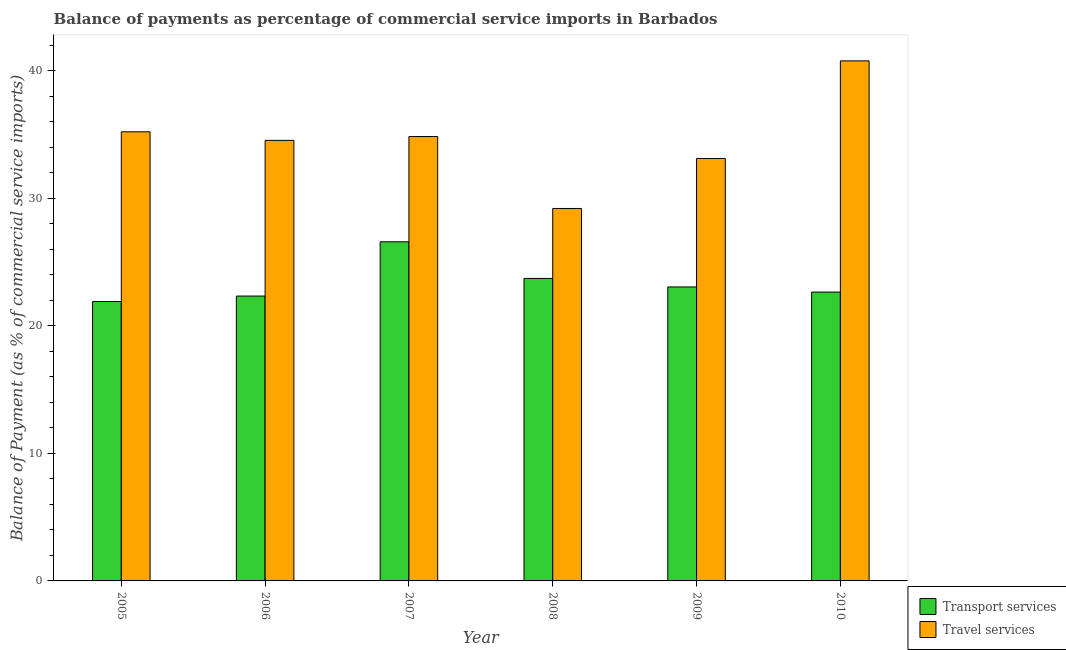How many different coloured bars are there?
Your response must be concise. 2. How many groups of bars are there?
Your response must be concise. 6. How many bars are there on the 1st tick from the right?
Offer a very short reply. 2. What is the label of the 2nd group of bars from the left?
Make the answer very short. 2006. What is the balance of payments of transport services in 2009?
Make the answer very short. 23.05. Across all years, what is the maximum balance of payments of transport services?
Offer a very short reply. 26.58. Across all years, what is the minimum balance of payments of travel services?
Offer a very short reply. 29.2. What is the total balance of payments of transport services in the graph?
Offer a very short reply. 140.22. What is the difference between the balance of payments of transport services in 2007 and that in 2008?
Keep it short and to the point. 2.87. What is the difference between the balance of payments of transport services in 2010 and the balance of payments of travel services in 2007?
Your response must be concise. -3.94. What is the average balance of payments of travel services per year?
Your answer should be compact. 34.61. What is the ratio of the balance of payments of transport services in 2007 to that in 2009?
Offer a very short reply. 1.15. Is the balance of payments of travel services in 2006 less than that in 2007?
Your answer should be very brief. Yes. What is the difference between the highest and the second highest balance of payments of travel services?
Offer a terse response. 5.56. What is the difference between the highest and the lowest balance of payments of transport services?
Provide a succinct answer. 4.68. What does the 1st bar from the left in 2008 represents?
Your response must be concise. Transport services. What does the 2nd bar from the right in 2006 represents?
Your answer should be very brief. Transport services. Are all the bars in the graph horizontal?
Give a very brief answer. No. What is the difference between two consecutive major ticks on the Y-axis?
Provide a succinct answer. 10. Does the graph contain any zero values?
Offer a terse response. No. Does the graph contain grids?
Offer a very short reply. No. What is the title of the graph?
Give a very brief answer. Balance of payments as percentage of commercial service imports in Barbados. What is the label or title of the X-axis?
Provide a succinct answer. Year. What is the label or title of the Y-axis?
Provide a succinct answer. Balance of Payment (as % of commercial service imports). What is the Balance of Payment (as % of commercial service imports) of Transport services in 2005?
Give a very brief answer. 21.91. What is the Balance of Payment (as % of commercial service imports) of Travel services in 2005?
Provide a succinct answer. 35.21. What is the Balance of Payment (as % of commercial service imports) in Transport services in 2006?
Provide a succinct answer. 22.33. What is the Balance of Payment (as % of commercial service imports) in Travel services in 2006?
Keep it short and to the point. 34.54. What is the Balance of Payment (as % of commercial service imports) of Transport services in 2007?
Give a very brief answer. 26.58. What is the Balance of Payment (as % of commercial service imports) of Travel services in 2007?
Provide a succinct answer. 34.84. What is the Balance of Payment (as % of commercial service imports) of Transport services in 2008?
Provide a succinct answer. 23.71. What is the Balance of Payment (as % of commercial service imports) in Travel services in 2008?
Offer a terse response. 29.2. What is the Balance of Payment (as % of commercial service imports) in Transport services in 2009?
Ensure brevity in your answer.  23.05. What is the Balance of Payment (as % of commercial service imports) in Travel services in 2009?
Keep it short and to the point. 33.12. What is the Balance of Payment (as % of commercial service imports) of Transport services in 2010?
Your answer should be very brief. 22.64. What is the Balance of Payment (as % of commercial service imports) in Travel services in 2010?
Offer a terse response. 40.77. Across all years, what is the maximum Balance of Payment (as % of commercial service imports) in Transport services?
Your answer should be compact. 26.58. Across all years, what is the maximum Balance of Payment (as % of commercial service imports) in Travel services?
Give a very brief answer. 40.77. Across all years, what is the minimum Balance of Payment (as % of commercial service imports) in Transport services?
Your answer should be very brief. 21.91. Across all years, what is the minimum Balance of Payment (as % of commercial service imports) in Travel services?
Give a very brief answer. 29.2. What is the total Balance of Payment (as % of commercial service imports) of Transport services in the graph?
Provide a succinct answer. 140.22. What is the total Balance of Payment (as % of commercial service imports) in Travel services in the graph?
Offer a terse response. 207.66. What is the difference between the Balance of Payment (as % of commercial service imports) of Transport services in 2005 and that in 2006?
Make the answer very short. -0.43. What is the difference between the Balance of Payment (as % of commercial service imports) of Travel services in 2005 and that in 2006?
Provide a succinct answer. 0.67. What is the difference between the Balance of Payment (as % of commercial service imports) in Transport services in 2005 and that in 2007?
Keep it short and to the point. -4.68. What is the difference between the Balance of Payment (as % of commercial service imports) of Travel services in 2005 and that in 2007?
Offer a very short reply. 0.37. What is the difference between the Balance of Payment (as % of commercial service imports) in Transport services in 2005 and that in 2008?
Offer a terse response. -1.81. What is the difference between the Balance of Payment (as % of commercial service imports) of Travel services in 2005 and that in 2008?
Provide a succinct answer. 6.01. What is the difference between the Balance of Payment (as % of commercial service imports) of Transport services in 2005 and that in 2009?
Provide a short and direct response. -1.14. What is the difference between the Balance of Payment (as % of commercial service imports) in Travel services in 2005 and that in 2009?
Make the answer very short. 2.09. What is the difference between the Balance of Payment (as % of commercial service imports) in Transport services in 2005 and that in 2010?
Make the answer very short. -0.74. What is the difference between the Balance of Payment (as % of commercial service imports) of Travel services in 2005 and that in 2010?
Offer a terse response. -5.56. What is the difference between the Balance of Payment (as % of commercial service imports) in Transport services in 2006 and that in 2007?
Offer a very short reply. -4.25. What is the difference between the Balance of Payment (as % of commercial service imports) in Travel services in 2006 and that in 2007?
Provide a short and direct response. -0.3. What is the difference between the Balance of Payment (as % of commercial service imports) in Transport services in 2006 and that in 2008?
Make the answer very short. -1.38. What is the difference between the Balance of Payment (as % of commercial service imports) of Travel services in 2006 and that in 2008?
Your answer should be compact. 5.34. What is the difference between the Balance of Payment (as % of commercial service imports) in Transport services in 2006 and that in 2009?
Provide a succinct answer. -0.71. What is the difference between the Balance of Payment (as % of commercial service imports) of Travel services in 2006 and that in 2009?
Provide a short and direct response. 1.42. What is the difference between the Balance of Payment (as % of commercial service imports) of Transport services in 2006 and that in 2010?
Make the answer very short. -0.31. What is the difference between the Balance of Payment (as % of commercial service imports) in Travel services in 2006 and that in 2010?
Keep it short and to the point. -6.23. What is the difference between the Balance of Payment (as % of commercial service imports) in Transport services in 2007 and that in 2008?
Your answer should be compact. 2.87. What is the difference between the Balance of Payment (as % of commercial service imports) of Travel services in 2007 and that in 2008?
Provide a succinct answer. 5.64. What is the difference between the Balance of Payment (as % of commercial service imports) of Transport services in 2007 and that in 2009?
Your answer should be compact. 3.54. What is the difference between the Balance of Payment (as % of commercial service imports) in Travel services in 2007 and that in 2009?
Offer a terse response. 1.72. What is the difference between the Balance of Payment (as % of commercial service imports) in Transport services in 2007 and that in 2010?
Make the answer very short. 3.94. What is the difference between the Balance of Payment (as % of commercial service imports) of Travel services in 2007 and that in 2010?
Provide a short and direct response. -5.93. What is the difference between the Balance of Payment (as % of commercial service imports) in Transport services in 2008 and that in 2009?
Make the answer very short. 0.67. What is the difference between the Balance of Payment (as % of commercial service imports) of Travel services in 2008 and that in 2009?
Ensure brevity in your answer.  -3.92. What is the difference between the Balance of Payment (as % of commercial service imports) in Transport services in 2008 and that in 2010?
Your response must be concise. 1.07. What is the difference between the Balance of Payment (as % of commercial service imports) in Travel services in 2008 and that in 2010?
Offer a very short reply. -11.57. What is the difference between the Balance of Payment (as % of commercial service imports) of Transport services in 2009 and that in 2010?
Your answer should be very brief. 0.4. What is the difference between the Balance of Payment (as % of commercial service imports) of Travel services in 2009 and that in 2010?
Ensure brevity in your answer.  -7.65. What is the difference between the Balance of Payment (as % of commercial service imports) of Transport services in 2005 and the Balance of Payment (as % of commercial service imports) of Travel services in 2006?
Provide a succinct answer. -12.63. What is the difference between the Balance of Payment (as % of commercial service imports) of Transport services in 2005 and the Balance of Payment (as % of commercial service imports) of Travel services in 2007?
Give a very brief answer. -12.93. What is the difference between the Balance of Payment (as % of commercial service imports) in Transport services in 2005 and the Balance of Payment (as % of commercial service imports) in Travel services in 2008?
Offer a very short reply. -7.29. What is the difference between the Balance of Payment (as % of commercial service imports) in Transport services in 2005 and the Balance of Payment (as % of commercial service imports) in Travel services in 2009?
Give a very brief answer. -11.21. What is the difference between the Balance of Payment (as % of commercial service imports) in Transport services in 2005 and the Balance of Payment (as % of commercial service imports) in Travel services in 2010?
Offer a very short reply. -18.86. What is the difference between the Balance of Payment (as % of commercial service imports) of Transport services in 2006 and the Balance of Payment (as % of commercial service imports) of Travel services in 2007?
Your answer should be compact. -12.51. What is the difference between the Balance of Payment (as % of commercial service imports) of Transport services in 2006 and the Balance of Payment (as % of commercial service imports) of Travel services in 2008?
Offer a very short reply. -6.87. What is the difference between the Balance of Payment (as % of commercial service imports) of Transport services in 2006 and the Balance of Payment (as % of commercial service imports) of Travel services in 2009?
Provide a short and direct response. -10.79. What is the difference between the Balance of Payment (as % of commercial service imports) of Transport services in 2006 and the Balance of Payment (as % of commercial service imports) of Travel services in 2010?
Give a very brief answer. -18.44. What is the difference between the Balance of Payment (as % of commercial service imports) of Transport services in 2007 and the Balance of Payment (as % of commercial service imports) of Travel services in 2008?
Offer a very short reply. -2.61. What is the difference between the Balance of Payment (as % of commercial service imports) in Transport services in 2007 and the Balance of Payment (as % of commercial service imports) in Travel services in 2009?
Provide a short and direct response. -6.53. What is the difference between the Balance of Payment (as % of commercial service imports) in Transport services in 2007 and the Balance of Payment (as % of commercial service imports) in Travel services in 2010?
Offer a very short reply. -14.18. What is the difference between the Balance of Payment (as % of commercial service imports) of Transport services in 2008 and the Balance of Payment (as % of commercial service imports) of Travel services in 2009?
Ensure brevity in your answer.  -9.4. What is the difference between the Balance of Payment (as % of commercial service imports) of Transport services in 2008 and the Balance of Payment (as % of commercial service imports) of Travel services in 2010?
Your response must be concise. -17.06. What is the difference between the Balance of Payment (as % of commercial service imports) in Transport services in 2009 and the Balance of Payment (as % of commercial service imports) in Travel services in 2010?
Your answer should be compact. -17.72. What is the average Balance of Payment (as % of commercial service imports) of Transport services per year?
Keep it short and to the point. 23.37. What is the average Balance of Payment (as % of commercial service imports) in Travel services per year?
Give a very brief answer. 34.61. In the year 2005, what is the difference between the Balance of Payment (as % of commercial service imports) of Transport services and Balance of Payment (as % of commercial service imports) of Travel services?
Give a very brief answer. -13.3. In the year 2006, what is the difference between the Balance of Payment (as % of commercial service imports) of Transport services and Balance of Payment (as % of commercial service imports) of Travel services?
Keep it short and to the point. -12.2. In the year 2007, what is the difference between the Balance of Payment (as % of commercial service imports) in Transport services and Balance of Payment (as % of commercial service imports) in Travel services?
Your answer should be compact. -8.25. In the year 2008, what is the difference between the Balance of Payment (as % of commercial service imports) in Transport services and Balance of Payment (as % of commercial service imports) in Travel services?
Offer a very short reply. -5.49. In the year 2009, what is the difference between the Balance of Payment (as % of commercial service imports) of Transport services and Balance of Payment (as % of commercial service imports) of Travel services?
Give a very brief answer. -10.07. In the year 2010, what is the difference between the Balance of Payment (as % of commercial service imports) of Transport services and Balance of Payment (as % of commercial service imports) of Travel services?
Ensure brevity in your answer.  -18.12. What is the ratio of the Balance of Payment (as % of commercial service imports) in Transport services in 2005 to that in 2006?
Your answer should be compact. 0.98. What is the ratio of the Balance of Payment (as % of commercial service imports) of Travel services in 2005 to that in 2006?
Provide a short and direct response. 1.02. What is the ratio of the Balance of Payment (as % of commercial service imports) in Transport services in 2005 to that in 2007?
Offer a terse response. 0.82. What is the ratio of the Balance of Payment (as % of commercial service imports) of Travel services in 2005 to that in 2007?
Keep it short and to the point. 1.01. What is the ratio of the Balance of Payment (as % of commercial service imports) of Transport services in 2005 to that in 2008?
Give a very brief answer. 0.92. What is the ratio of the Balance of Payment (as % of commercial service imports) of Travel services in 2005 to that in 2008?
Your response must be concise. 1.21. What is the ratio of the Balance of Payment (as % of commercial service imports) of Transport services in 2005 to that in 2009?
Provide a short and direct response. 0.95. What is the ratio of the Balance of Payment (as % of commercial service imports) in Travel services in 2005 to that in 2009?
Your answer should be compact. 1.06. What is the ratio of the Balance of Payment (as % of commercial service imports) in Transport services in 2005 to that in 2010?
Keep it short and to the point. 0.97. What is the ratio of the Balance of Payment (as % of commercial service imports) in Travel services in 2005 to that in 2010?
Offer a terse response. 0.86. What is the ratio of the Balance of Payment (as % of commercial service imports) in Transport services in 2006 to that in 2007?
Ensure brevity in your answer.  0.84. What is the ratio of the Balance of Payment (as % of commercial service imports) in Transport services in 2006 to that in 2008?
Ensure brevity in your answer.  0.94. What is the ratio of the Balance of Payment (as % of commercial service imports) of Travel services in 2006 to that in 2008?
Your response must be concise. 1.18. What is the ratio of the Balance of Payment (as % of commercial service imports) in Transport services in 2006 to that in 2009?
Keep it short and to the point. 0.97. What is the ratio of the Balance of Payment (as % of commercial service imports) in Travel services in 2006 to that in 2009?
Your response must be concise. 1.04. What is the ratio of the Balance of Payment (as % of commercial service imports) in Transport services in 2006 to that in 2010?
Your response must be concise. 0.99. What is the ratio of the Balance of Payment (as % of commercial service imports) in Travel services in 2006 to that in 2010?
Your answer should be compact. 0.85. What is the ratio of the Balance of Payment (as % of commercial service imports) in Transport services in 2007 to that in 2008?
Offer a terse response. 1.12. What is the ratio of the Balance of Payment (as % of commercial service imports) of Travel services in 2007 to that in 2008?
Make the answer very short. 1.19. What is the ratio of the Balance of Payment (as % of commercial service imports) in Transport services in 2007 to that in 2009?
Give a very brief answer. 1.15. What is the ratio of the Balance of Payment (as % of commercial service imports) of Travel services in 2007 to that in 2009?
Provide a short and direct response. 1.05. What is the ratio of the Balance of Payment (as % of commercial service imports) in Transport services in 2007 to that in 2010?
Your response must be concise. 1.17. What is the ratio of the Balance of Payment (as % of commercial service imports) in Travel services in 2007 to that in 2010?
Give a very brief answer. 0.85. What is the ratio of the Balance of Payment (as % of commercial service imports) of Transport services in 2008 to that in 2009?
Keep it short and to the point. 1.03. What is the ratio of the Balance of Payment (as % of commercial service imports) in Travel services in 2008 to that in 2009?
Ensure brevity in your answer.  0.88. What is the ratio of the Balance of Payment (as % of commercial service imports) of Transport services in 2008 to that in 2010?
Your response must be concise. 1.05. What is the ratio of the Balance of Payment (as % of commercial service imports) in Travel services in 2008 to that in 2010?
Your answer should be very brief. 0.72. What is the ratio of the Balance of Payment (as % of commercial service imports) in Transport services in 2009 to that in 2010?
Your answer should be very brief. 1.02. What is the ratio of the Balance of Payment (as % of commercial service imports) in Travel services in 2009 to that in 2010?
Offer a very short reply. 0.81. What is the difference between the highest and the second highest Balance of Payment (as % of commercial service imports) of Transport services?
Ensure brevity in your answer.  2.87. What is the difference between the highest and the second highest Balance of Payment (as % of commercial service imports) in Travel services?
Your response must be concise. 5.56. What is the difference between the highest and the lowest Balance of Payment (as % of commercial service imports) in Transport services?
Keep it short and to the point. 4.68. What is the difference between the highest and the lowest Balance of Payment (as % of commercial service imports) in Travel services?
Offer a very short reply. 11.57. 